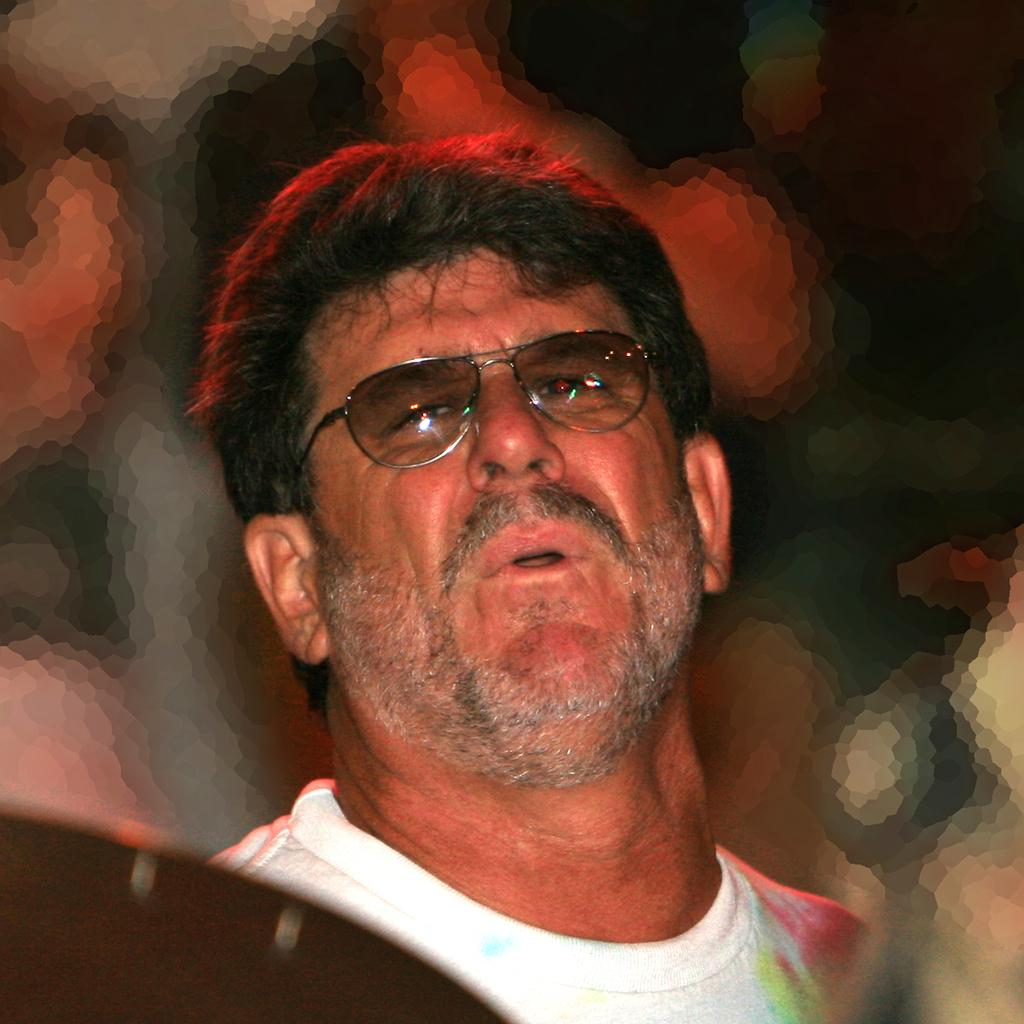What can be seen in the image? There is a person in the image. What is the person wearing? The person is wearing a white t-shirt and spectacles. Can you describe the background of the image? The background of the image is blurry. What type of drum is the person playing in the image? There is no drum present in the image; the person is simply wearing spectacles and a white t-shirt. 